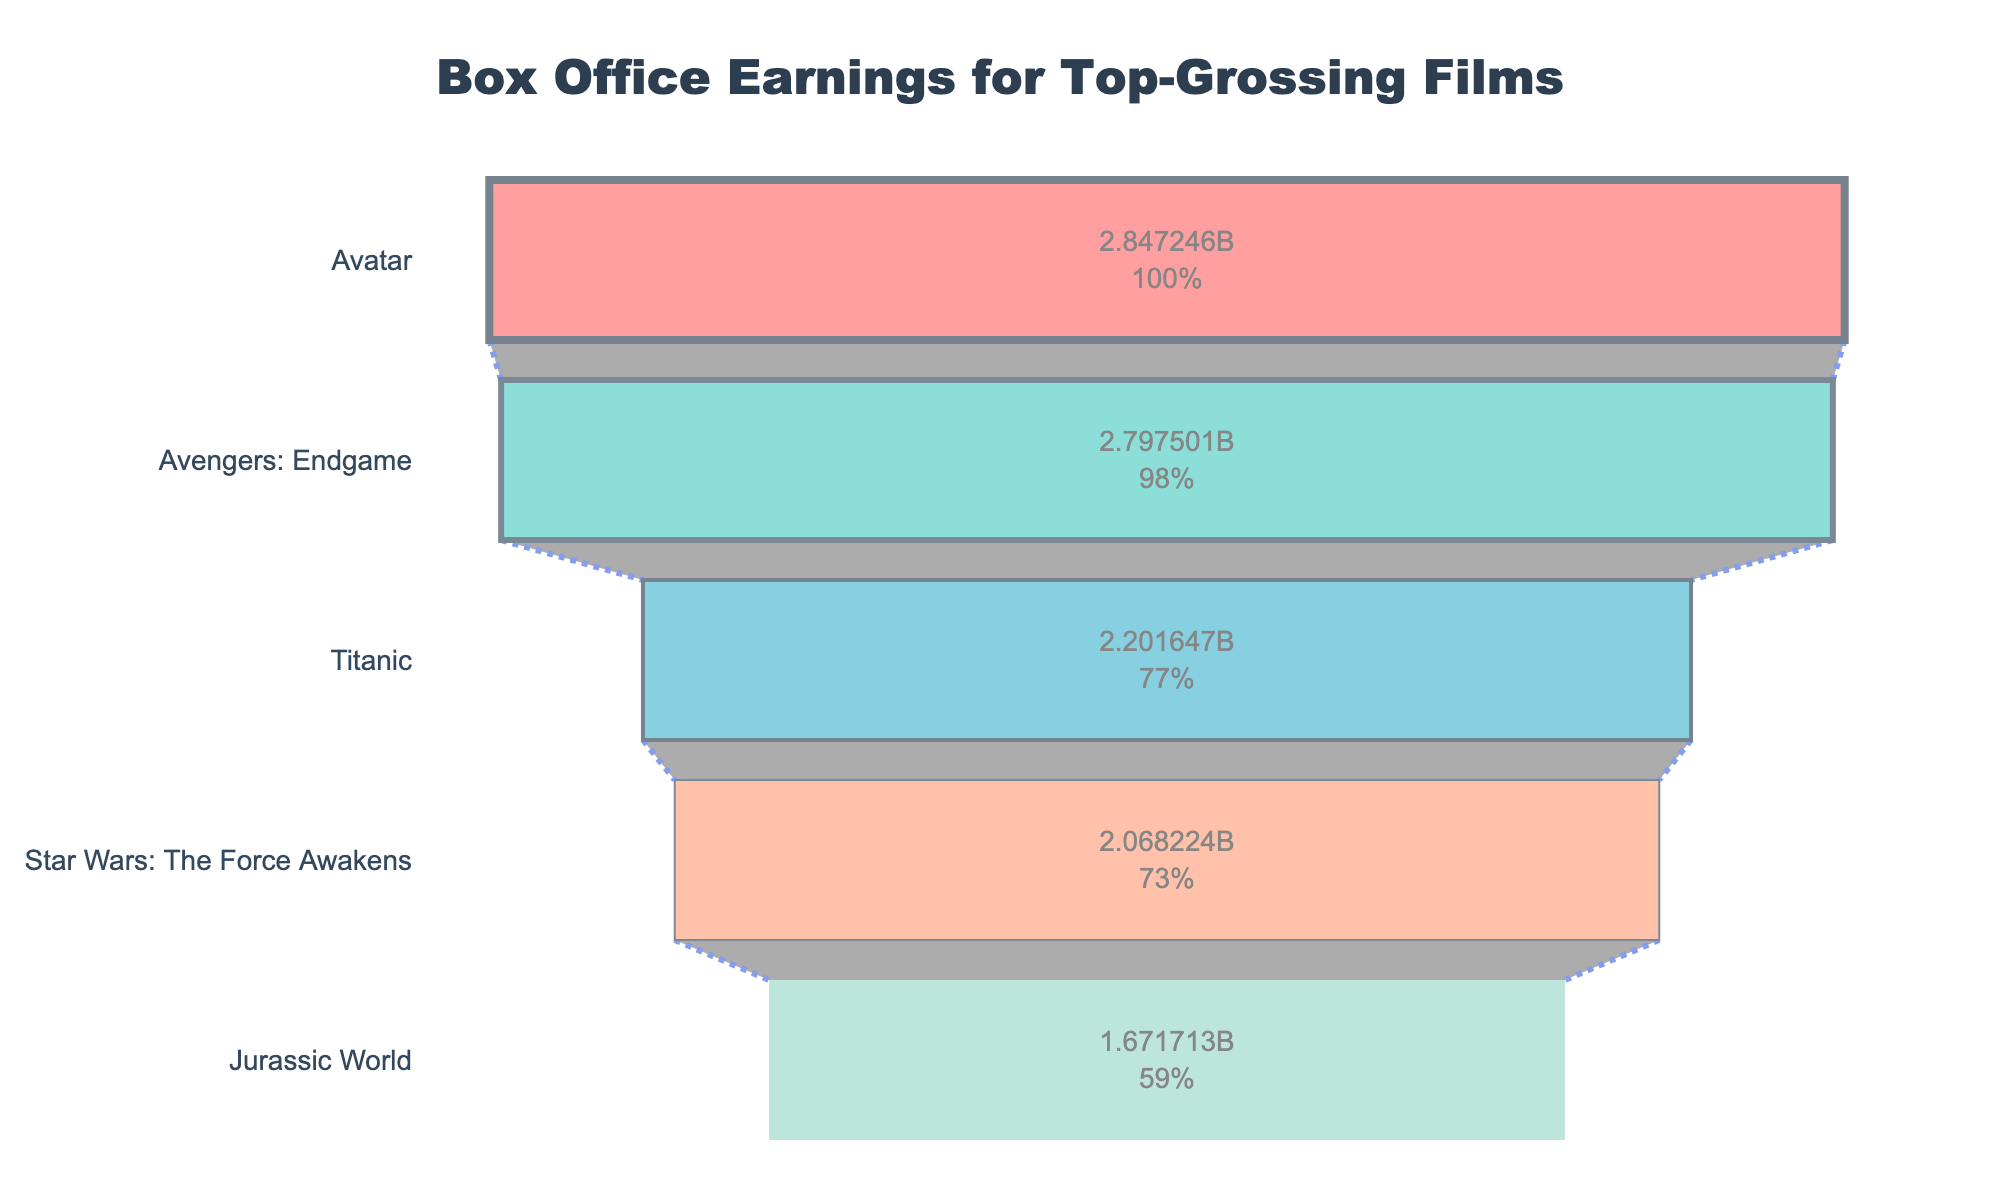What's the most lucrative film in this funnel chart? Look at the top of the funnel chart; the film at the widest part is the most lucrative. "Avengers: Endgame" is at the top position indicating it has the highest earnings.
Answer: Avengers: Endgame How much did 'Avatar' gross in total? Check the section labeled 'Avatar' in the chart. The total gross value displayed inside the funnel section will indicate the earnings. The chart shows 'Avatar' grossed $2,847,246,203.
Answer: $2,847,246,203 Which film had the smallest box office earnings? Look at the bottom of the funnel chart where the section is the narrowest. The film at this position has the smallest earnings. 'Jurassic World' is at the bottom.
Answer: Jurassic World What's the total gross difference between 'Star Wars: The Force Awakens' and 'Titanic'? Find the total gross of both films in the funnel sections. 'Star Wars: The Force Awakens' has $2,068,223,624 and 'Titanic' has $2,201,647,264. Subtract the smaller number from the larger one: $2,201,647,264 - $2,068,223,624.
Answer: $133,423,640 Which film has a higher total gross, 'Titanic' or 'Jurassic World'? Compare the values inside the funnel sections for 'Titanic' and 'Jurassic World'. 'Titanic' is higher at $2,201,647,264 compared to 'Jurassic World' at $1,671,713,208.
Answer: Titanic What percentage of the total gross does 'Avatar' contribute initially, excluding all other films? Since 'Avatar' is the only film to initially consider, it contributes 100% of its own total gross, shown in the figure as 100%.
Answer: 100% How do the colors differentiate the films in the chart? Observe the funnel sections' color difference. Each film is represented by a unique color - 'Avengers: Endgame' in red, 'Avatar' in teal, 'Titanic' in blue, 'Star Wars: The Force Awakens' in light salmon, and 'Jurassic World' in light green.
Answer: Unique color for each film Is the funnel chart helpful to visualize which films generated the most revenue? The funnel chart visually organizes the films by their total gross earnings in a descending manner, making it easier to see which films generated more revenue by their position and size.
Answer: Yes What is the estimated difference in gross earnings between 'Avengers: Endgame' and 'Avatar'? Refer to the total gross values of both films: 'Avengers: Endgame' with $2,797,501,328 and 'Avatar' with $2,847,246,203. Deduct the smaller from the larger: $2,847,246,203 - $2,797,501,328.
Answer: $49,744,875 